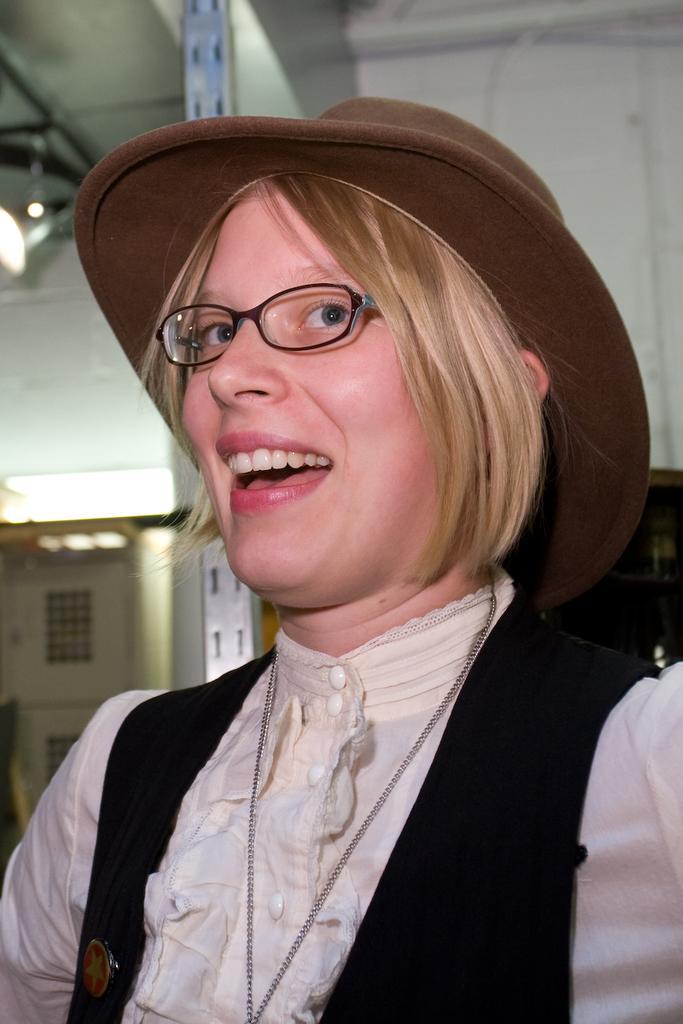Describe this image in one or two sentences. In the picture I can see women wearing spectacles, behind we can see light to the roof. 